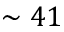<formula> <loc_0><loc_0><loc_500><loc_500>\sim 4 1</formula> 